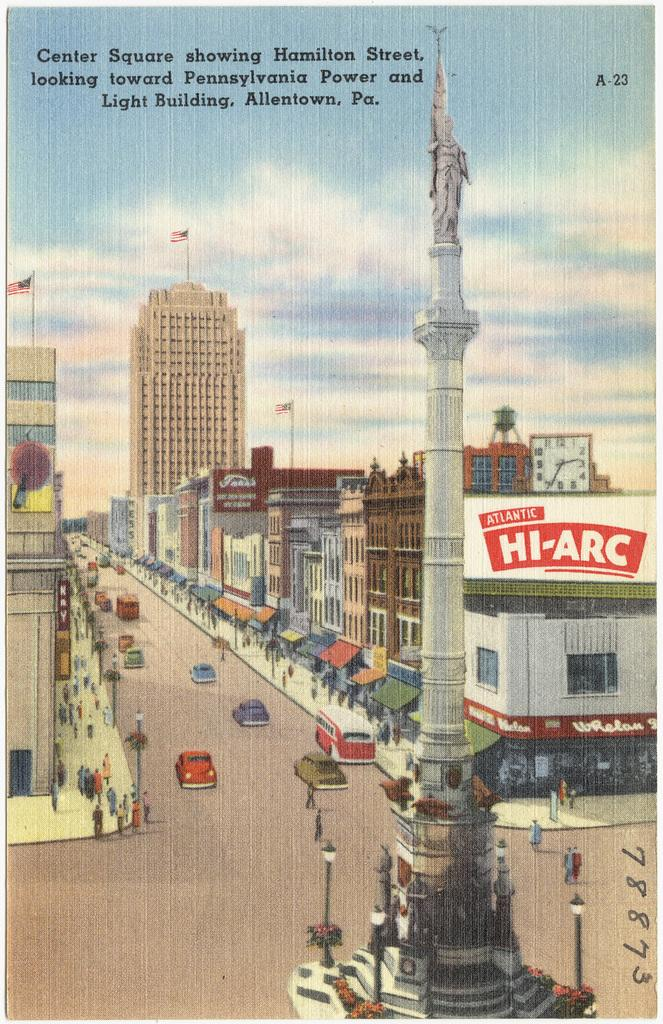What is the name of the central square in the image? The central square in the image is named Hamilton Street. What type of vehicles can be seen passing on the road in the image? Cars are passing on the road in the image. What structures are visible in the image? There are buildings visible in the image. What type of acoustics can be heard in the image? There is no information about acoustics in the image, as it only contains a photograph of a central square and cars passing on the road. Is there a volcano visible in the image? No, there is no volcano present in the image. 